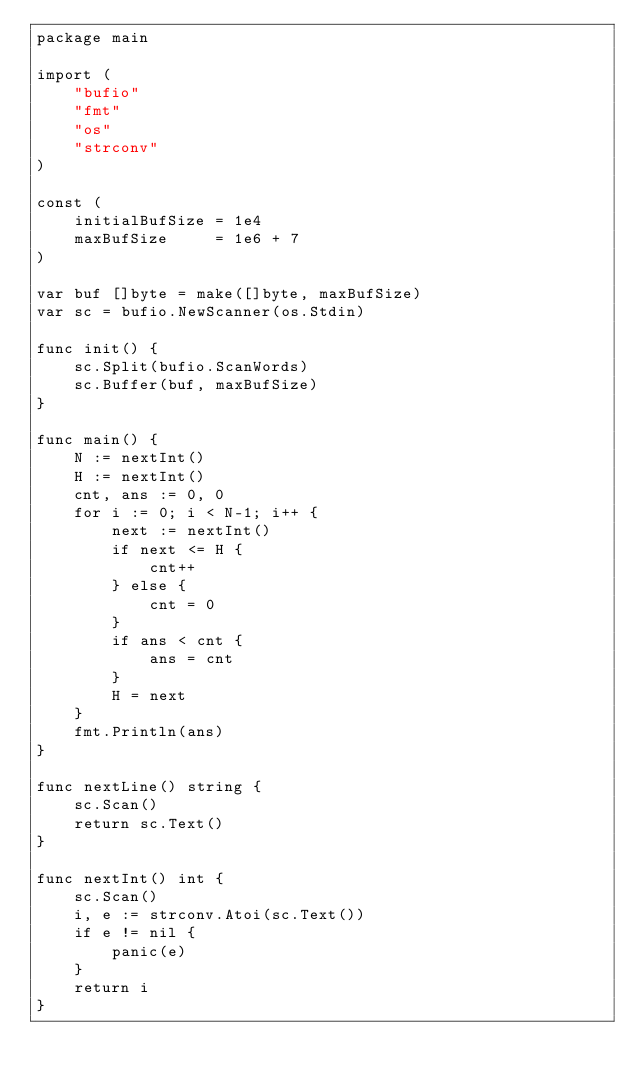<code> <loc_0><loc_0><loc_500><loc_500><_Go_>package main

import (
	"bufio"
	"fmt"
	"os"
	"strconv"
)

const (
	initialBufSize = 1e4
	maxBufSize     = 1e6 + 7
)

var buf []byte = make([]byte, maxBufSize)
var sc = bufio.NewScanner(os.Stdin)

func init() {
	sc.Split(bufio.ScanWords)
	sc.Buffer(buf, maxBufSize)
}

func main() {
	N := nextInt()
	H := nextInt()
	cnt, ans := 0, 0
	for i := 0; i < N-1; i++ {
		next := nextInt()
		if next <= H {
			cnt++
		} else {
			cnt = 0
		}
		if ans < cnt {
			ans = cnt
		}
		H = next
	}
	fmt.Println(ans)
}

func nextLine() string {
	sc.Scan()
	return sc.Text()
}

func nextInt() int {
	sc.Scan()
	i, e := strconv.Atoi(sc.Text())
	if e != nil {
		panic(e)
	}
	return i
}
</code> 